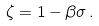<formula> <loc_0><loc_0><loc_500><loc_500>\zeta = 1 - \beta \sigma \, .</formula> 